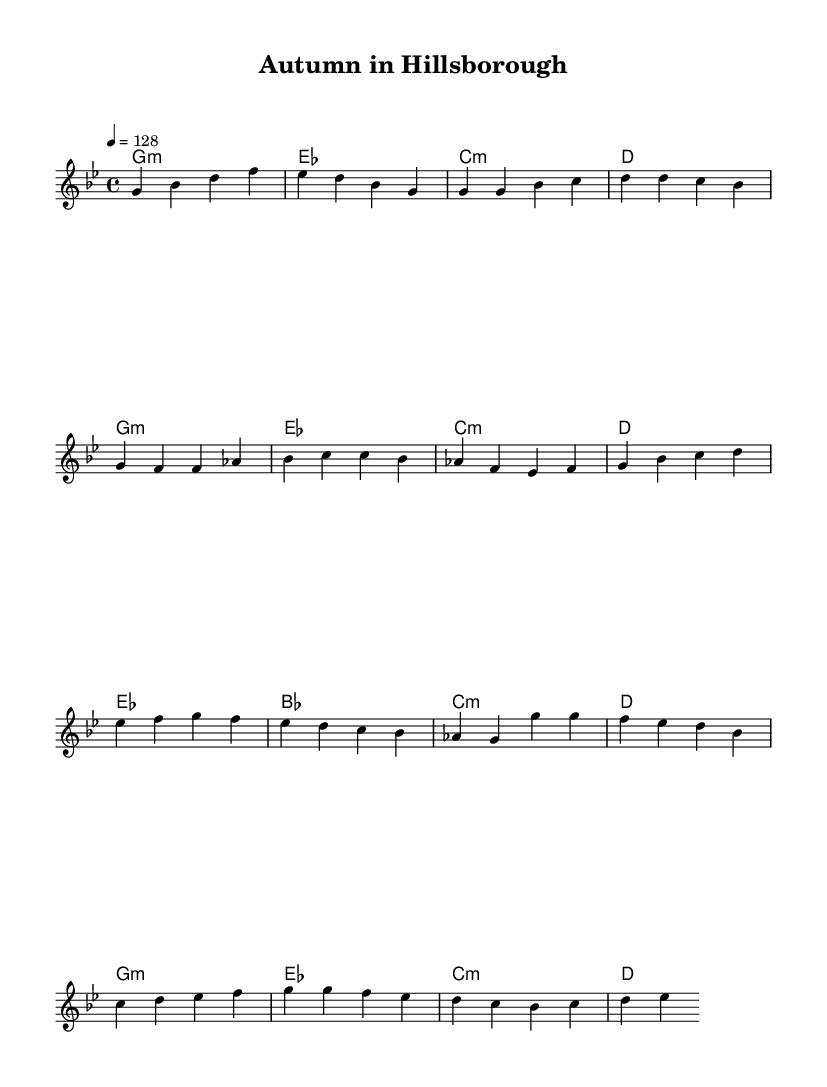What is the key signature of this music? The key signature is G minor, indicated by the presence of two flats (B♭ and E♭) at the beginning of the staff.
Answer: G minor What is the time signature of this music? The time signature is 4/4, which means there are four beats per measure, as shown at the beginning of the score.
Answer: 4/4 What is the tempo marking for this piece? The tempo marking indicates a speed of 128 beats per minute, which is noted as "4 = 128" at the start of the score.
Answer: 128 What is the chord for the first measure? The first measure shows a G minor chord, represented as "g1:m" in the harmonies section.
Answer: G minor How many measures are in the chorus section? The chorus consists of four measures, as identified by the sequential grouping of the notes in that part of the score.
Answer: Four measures What is the distinctive feature of K-Pop music within this piece? The piece includes a danceable rhythm and upbeat tempo typical of K-Pop and features structured sections like the verse, pre-chorus, and chorus.
Answer: Danceable rhythm 